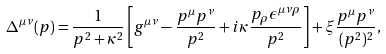<formula> <loc_0><loc_0><loc_500><loc_500>\Delta ^ { \mu \nu } ( p ) = \frac { 1 } { p ^ { 2 } + \kappa ^ { 2 } } \left [ g ^ { \mu \nu } - \frac { p ^ { \mu } p ^ { \nu } } { p ^ { 2 } } + i \kappa \frac { p _ { \rho } \epsilon ^ { \mu \nu \rho } } { p ^ { 2 } } \right ] + \xi \frac { p ^ { \mu } p ^ { \nu } } { ( p ^ { 2 } ) ^ { 2 } } ,</formula> 